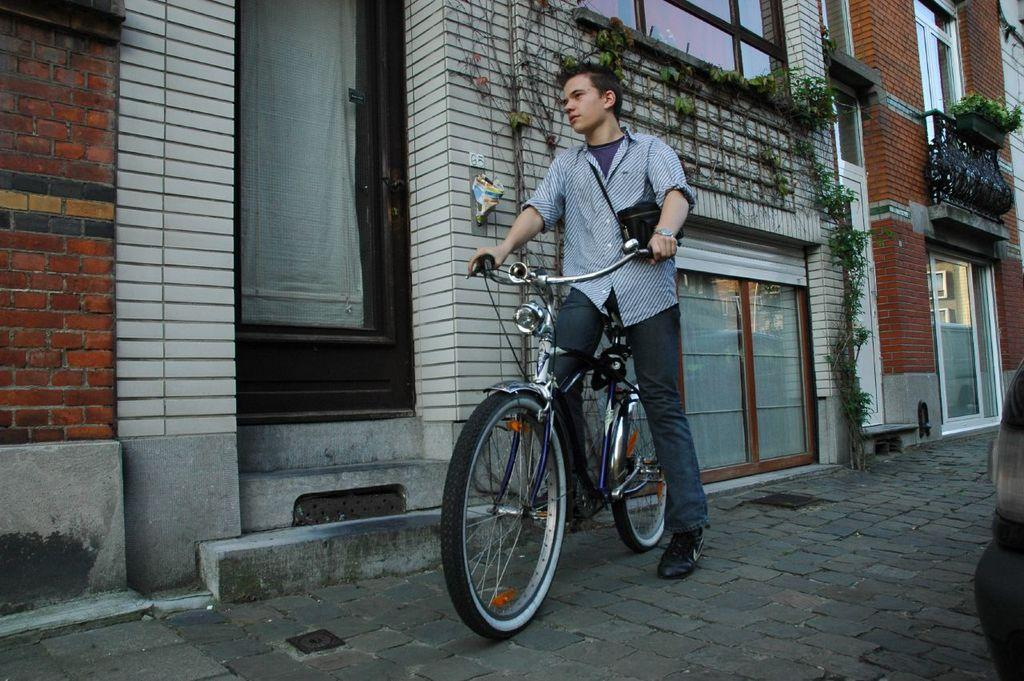What is the man in the image doing? The man is on a bicycle in the image. What is the setting of the image? There is a road in the image. What can be seen in the background of the image? There are plants and a building visible in the image. What part of the building can be seen in the image? There is a door in the image. What type of can is visible on the table in the image? There is no table or can present in the image. What is the relation between the man and the building in the image? The image does not provide information about the man's relation to the building. 